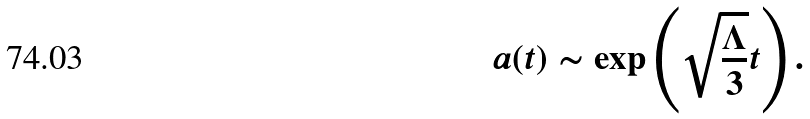<formula> <loc_0><loc_0><loc_500><loc_500>a ( t ) \sim \exp \left ( \sqrt { \frac { \Lambda } { 3 } } t \right ) .</formula> 